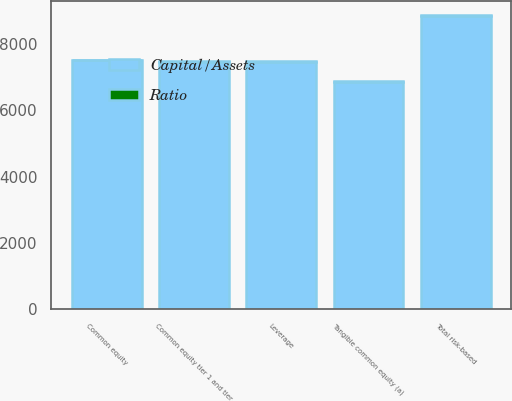Convert chart. <chart><loc_0><loc_0><loc_500><loc_500><stacked_bar_chart><ecel><fcel>Common equity tier 1 and tier<fcel>Total risk-based<fcel>Leverage<fcel>Common equity<fcel>Tangible common equity (a)<nl><fcel>Capital/Assets<fcel>7470<fcel>8855<fcel>7470<fcel>7507<fcel>6866<nl><fcel>Ratio<fcel>11.14<fcel>13.21<fcel>10.51<fcel>10.6<fcel>9.78<nl></chart> 